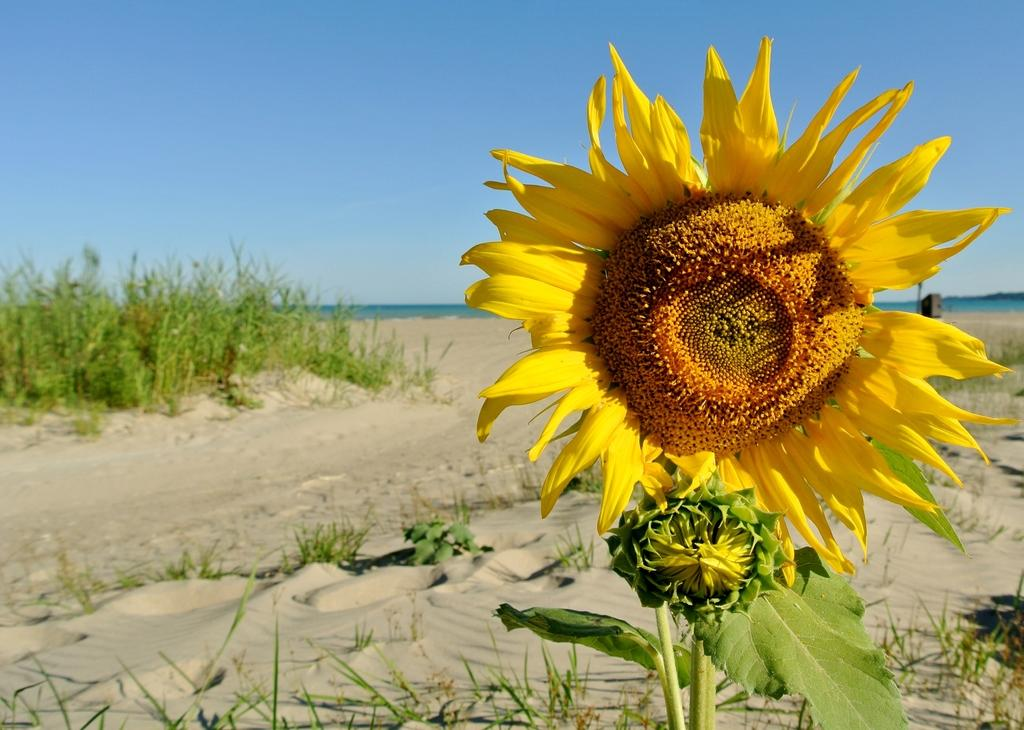What type of plant is on the right side of the image? There is a sunflower on the right side of the image. What is the color of the grass in the image? The grass is green in the image. What is the texture of the grass in the image? The grass is on sand, which suggests a sandy texture. What can be seen in the sky in the image? There are clouds in the sky in the image. Where is the nest located in the image? There is no nest present in the image. What point is being made in the image? The image does not convey a specific point or message; it is a visual representation of a sunflower, grass, and clouds. 